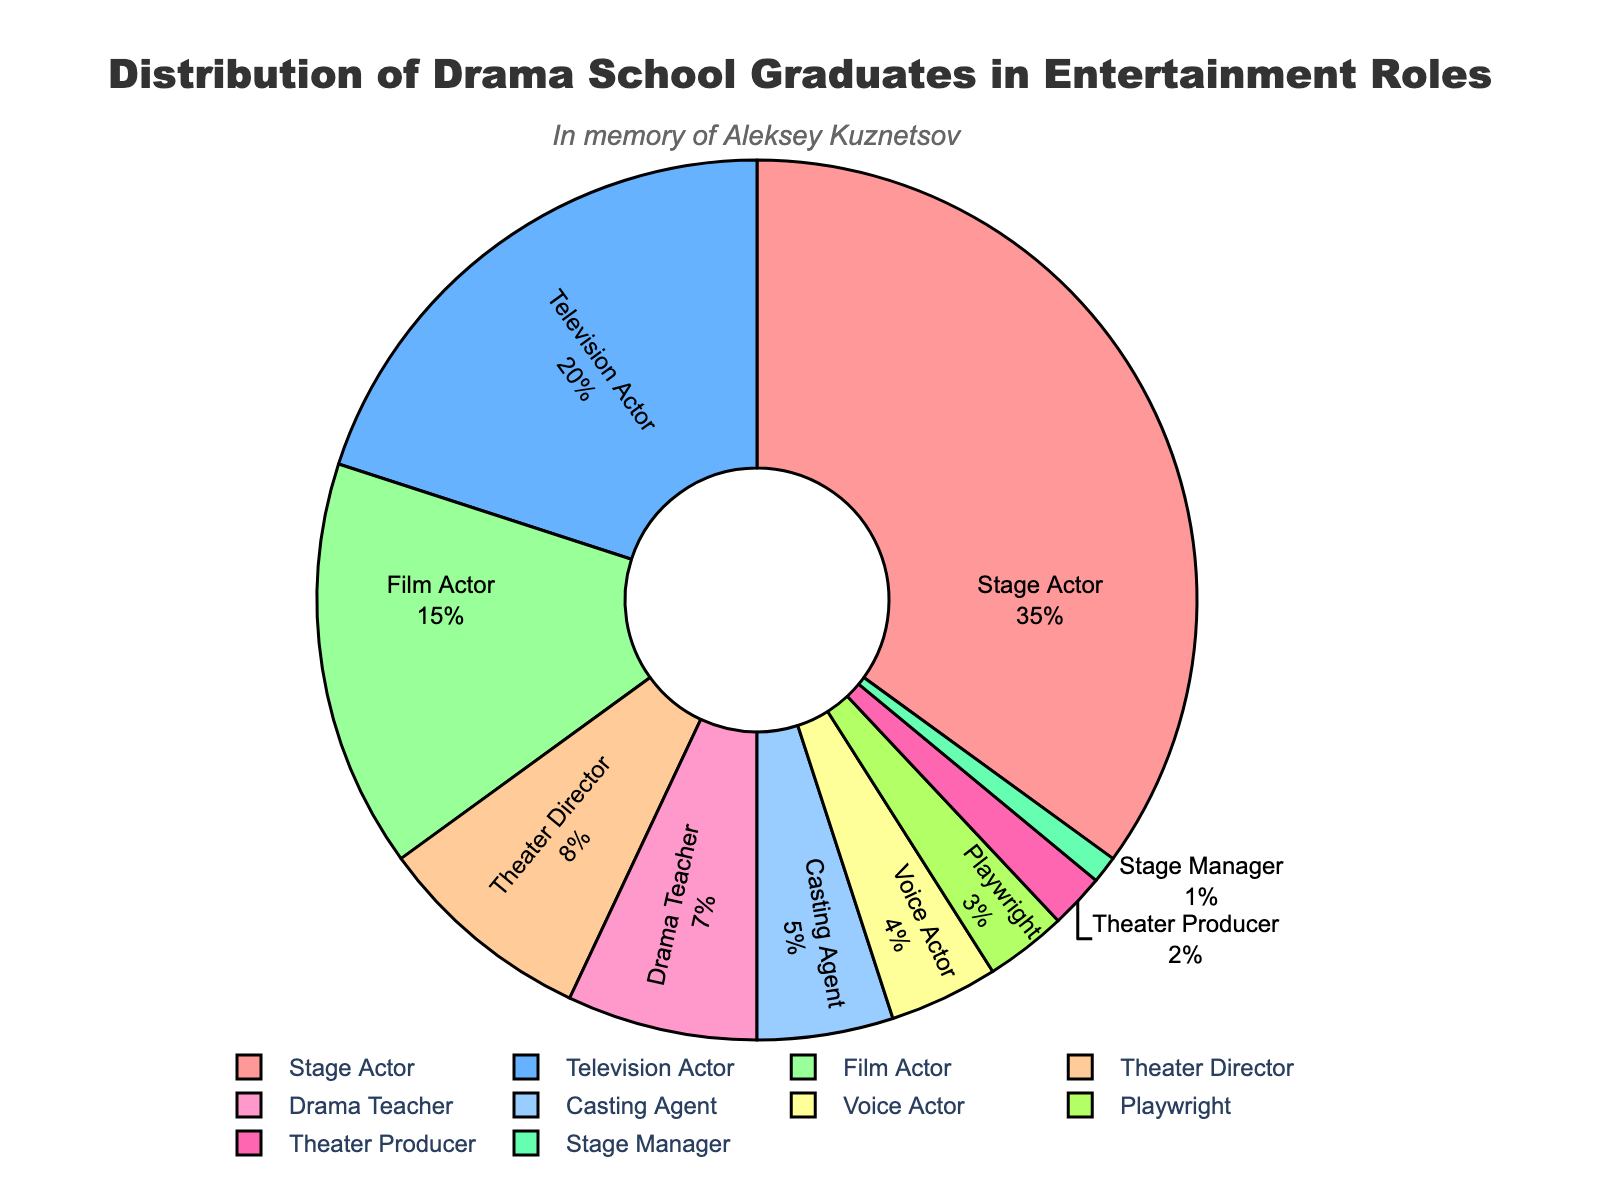What percentage of drama school graduates end up as Television Actors? To determine the percentage, directly refer to the section labeled "Television Actor" in the pie chart. The pie chart indicates the percentage within each labeled section.
Answer: 20% Which role has a higher percentage of drama school graduates, Drama Teacher or Film Actor? Compare the percentages of drama school graduates in the roles of Drama Teacher and Film Actor as shown in the pie chart. Drama Teacher has 7%, whereas Film Actor has 15%.
Answer: Film Actor What is the combined percentage of graduates in roles with less than 5% distribution each? Identify the roles with percentages less than 5% (Playwright, Theater Producer, Stage Manager, Voice Actor), and sum their percentages: 3% (Playwright) + 2% (Theater Producer) + 1% (Stage Manager) + 4% (Voice Actor) = 10%.
Answer: 10% How does the percentage of Stage Actors compare to the total percentage of Theater Directors and Drama Teachers combined? Stage Actor has 35%. Theater Director and Drama Teacher together have 8% + 7% = 15%. Compare these two values: 35% is greater than 15%.
Answer: Greater Which role has the smallest percentage of graduates? Locate the smallest section in the pie chart, labeled "Stage Manager," which has the smallest percentage.
Answer: Stage Manager Is the percentage of Film Actors greater than or less than the combined percentage of Drama Teachers and Theater Directors? Compare the percentages: Film Actor (15%) with Drama Teacher (7%) + Theater Director (8%) = 15%. They have equal percentages.
Answer: Equal What is the difference in distribution between Stage Actors and Voice Actors? Calculate the difference: Stage Actors (35%) - Voice Actors (4%) = 31%.
Answer: 31% What is the sum of the percentages for graduates in roles related to theater specifically (Stage Actor, Theater Director, Playwright, Theater Producer, Stage Manager)? Sum the percentages: Stage Actor (35%) + Theater Director (8%) + Playwright (3%) + Theater Producer (2%) + Stage Manager (1%) = 49%.
Answer: 49% Which two roles, if combined, would make up exactly 20% of the graduates? Identify combinations of roles whose percentages sum to 20%. E.g., Drama Teacher (7%) + Theater Director (8%) + Playwright (3%) + Stage Manager (1%) + Theater Producer (2%) = 20%.
Answer: Drama Teacher and Theater Director 